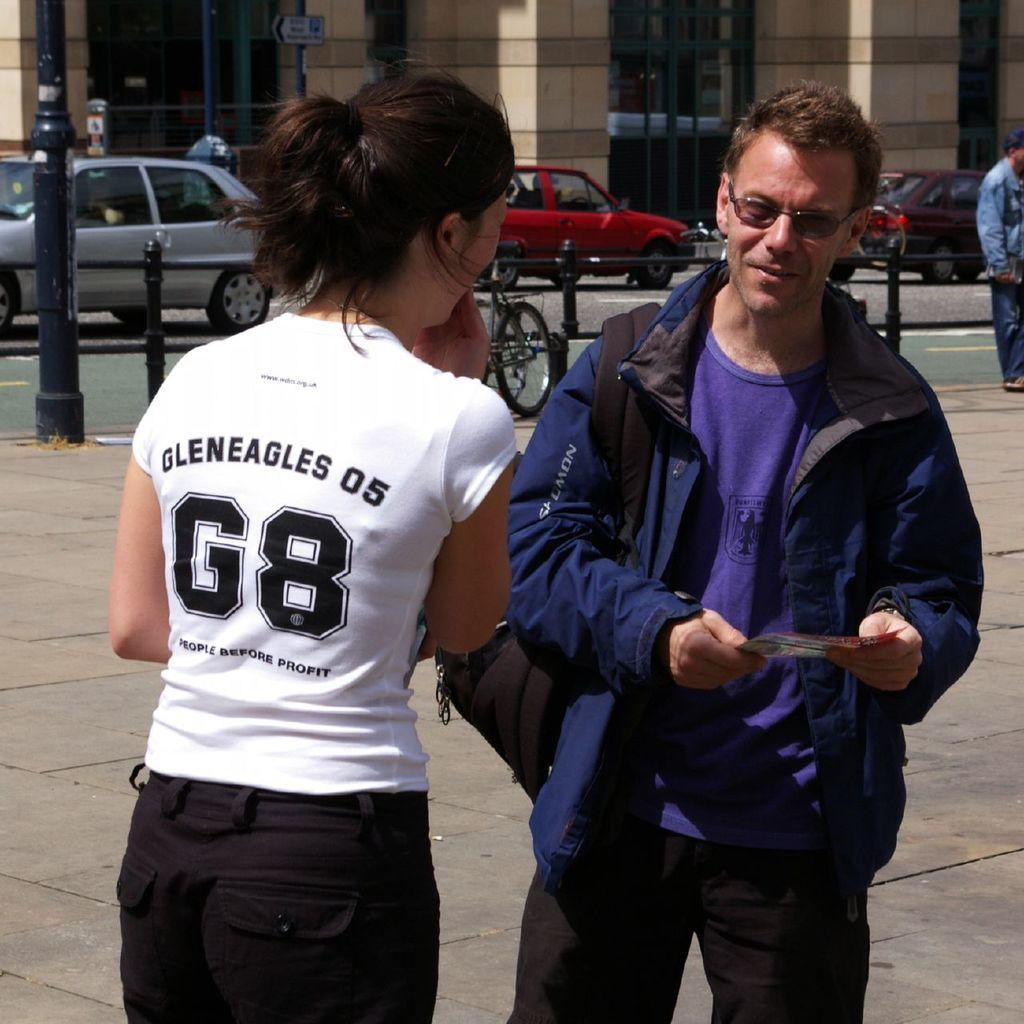How many people are in the image? There are three persons in the image. What mode of transportation can be seen in the image? There is a bicycle in the image. What type of vehicles are on the road in the image? There are cars on the road in the image. What structures are present in the image? There are poles and boards in the image. What can be seen in the background of the image? There is a building in the background of the image. What type of uncle is depicted in the image? There is no uncle present in the image. What experience can be gained from the boards in the image? The boards in the image do not offer any specific experience; they are simply objects present in the scene. 